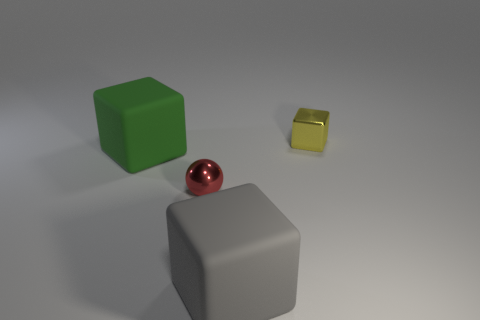Subtract all tiny metallic blocks. How many blocks are left? 2 Add 2 large brown metal cubes. How many objects exist? 6 Subtract all green cubes. How many cubes are left? 2 Subtract all spheres. How many objects are left? 3 Subtract 0 blue cylinders. How many objects are left? 4 Subtract all green spheres. Subtract all brown blocks. How many spheres are left? 1 Subtract all matte spheres. Subtract all big things. How many objects are left? 2 Add 2 tiny things. How many tiny things are left? 4 Add 4 small yellow objects. How many small yellow objects exist? 5 